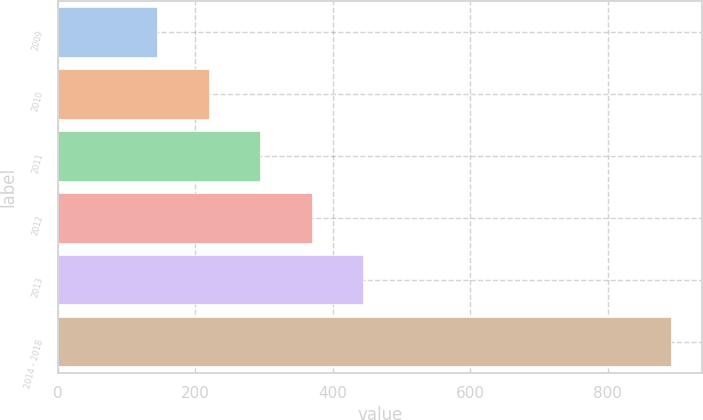Convert chart to OTSL. <chart><loc_0><loc_0><loc_500><loc_500><bar_chart><fcel>2009<fcel>2010<fcel>2011<fcel>2012<fcel>2013<fcel>2014 - 2018<nl><fcel>145<fcel>219.7<fcel>294.4<fcel>369.1<fcel>443.8<fcel>892<nl></chart> 